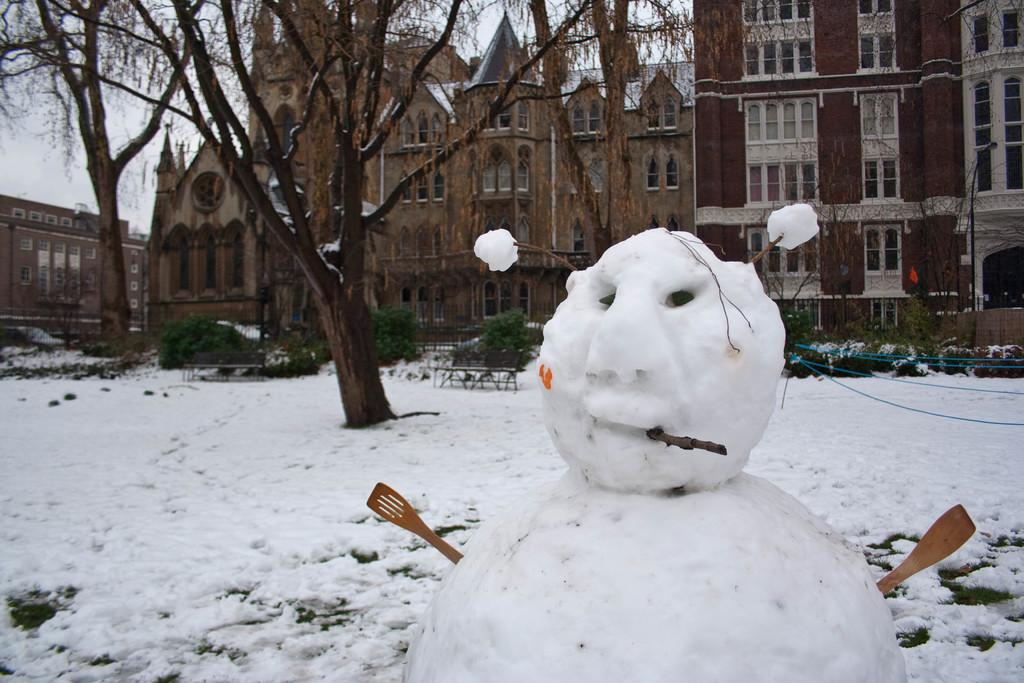What is the main subject of the image? There is a snowman in the image. Where is the snowman located? The snowman is standing on the ground. What is the condition of the ground in the image? The ground is covered with snow. What can be seen in the background of the image? There are trees and buildings visible in the image. What type of lunch is the snowman eating in the image? There is no indication in the image that the snowman is eating lunch, as snowmen do not consume food. 